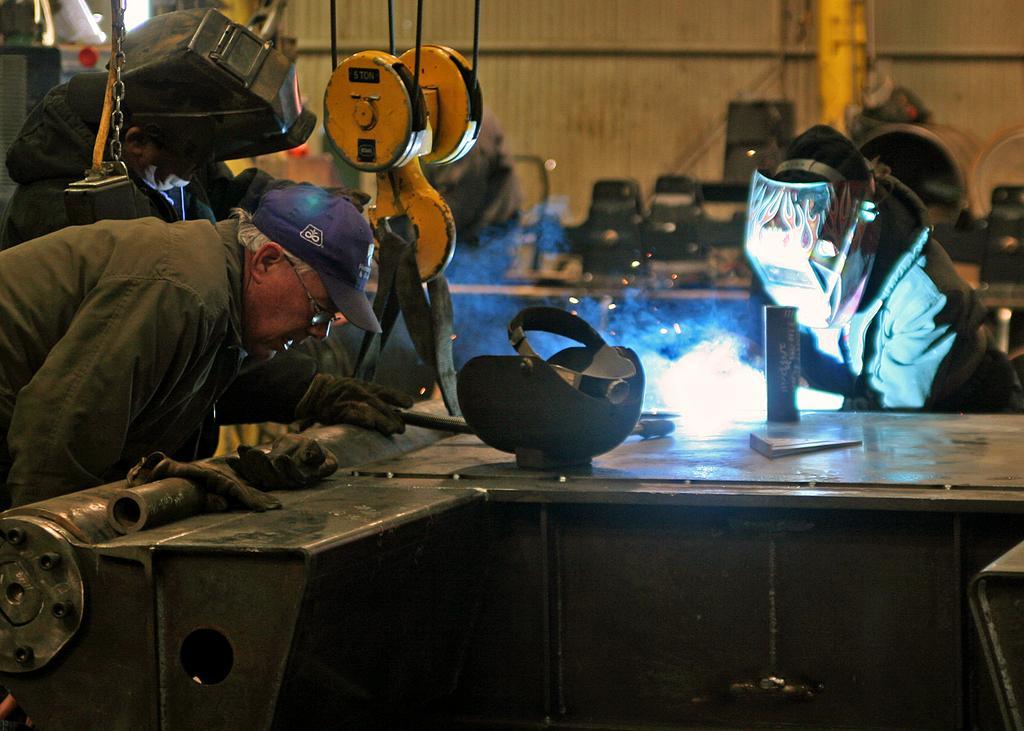Can you describe this image briefly? In this picture I can see some objects on the table, there are three persons standing, there are two persons with steel welding helmets, and in the background there are some objects. 